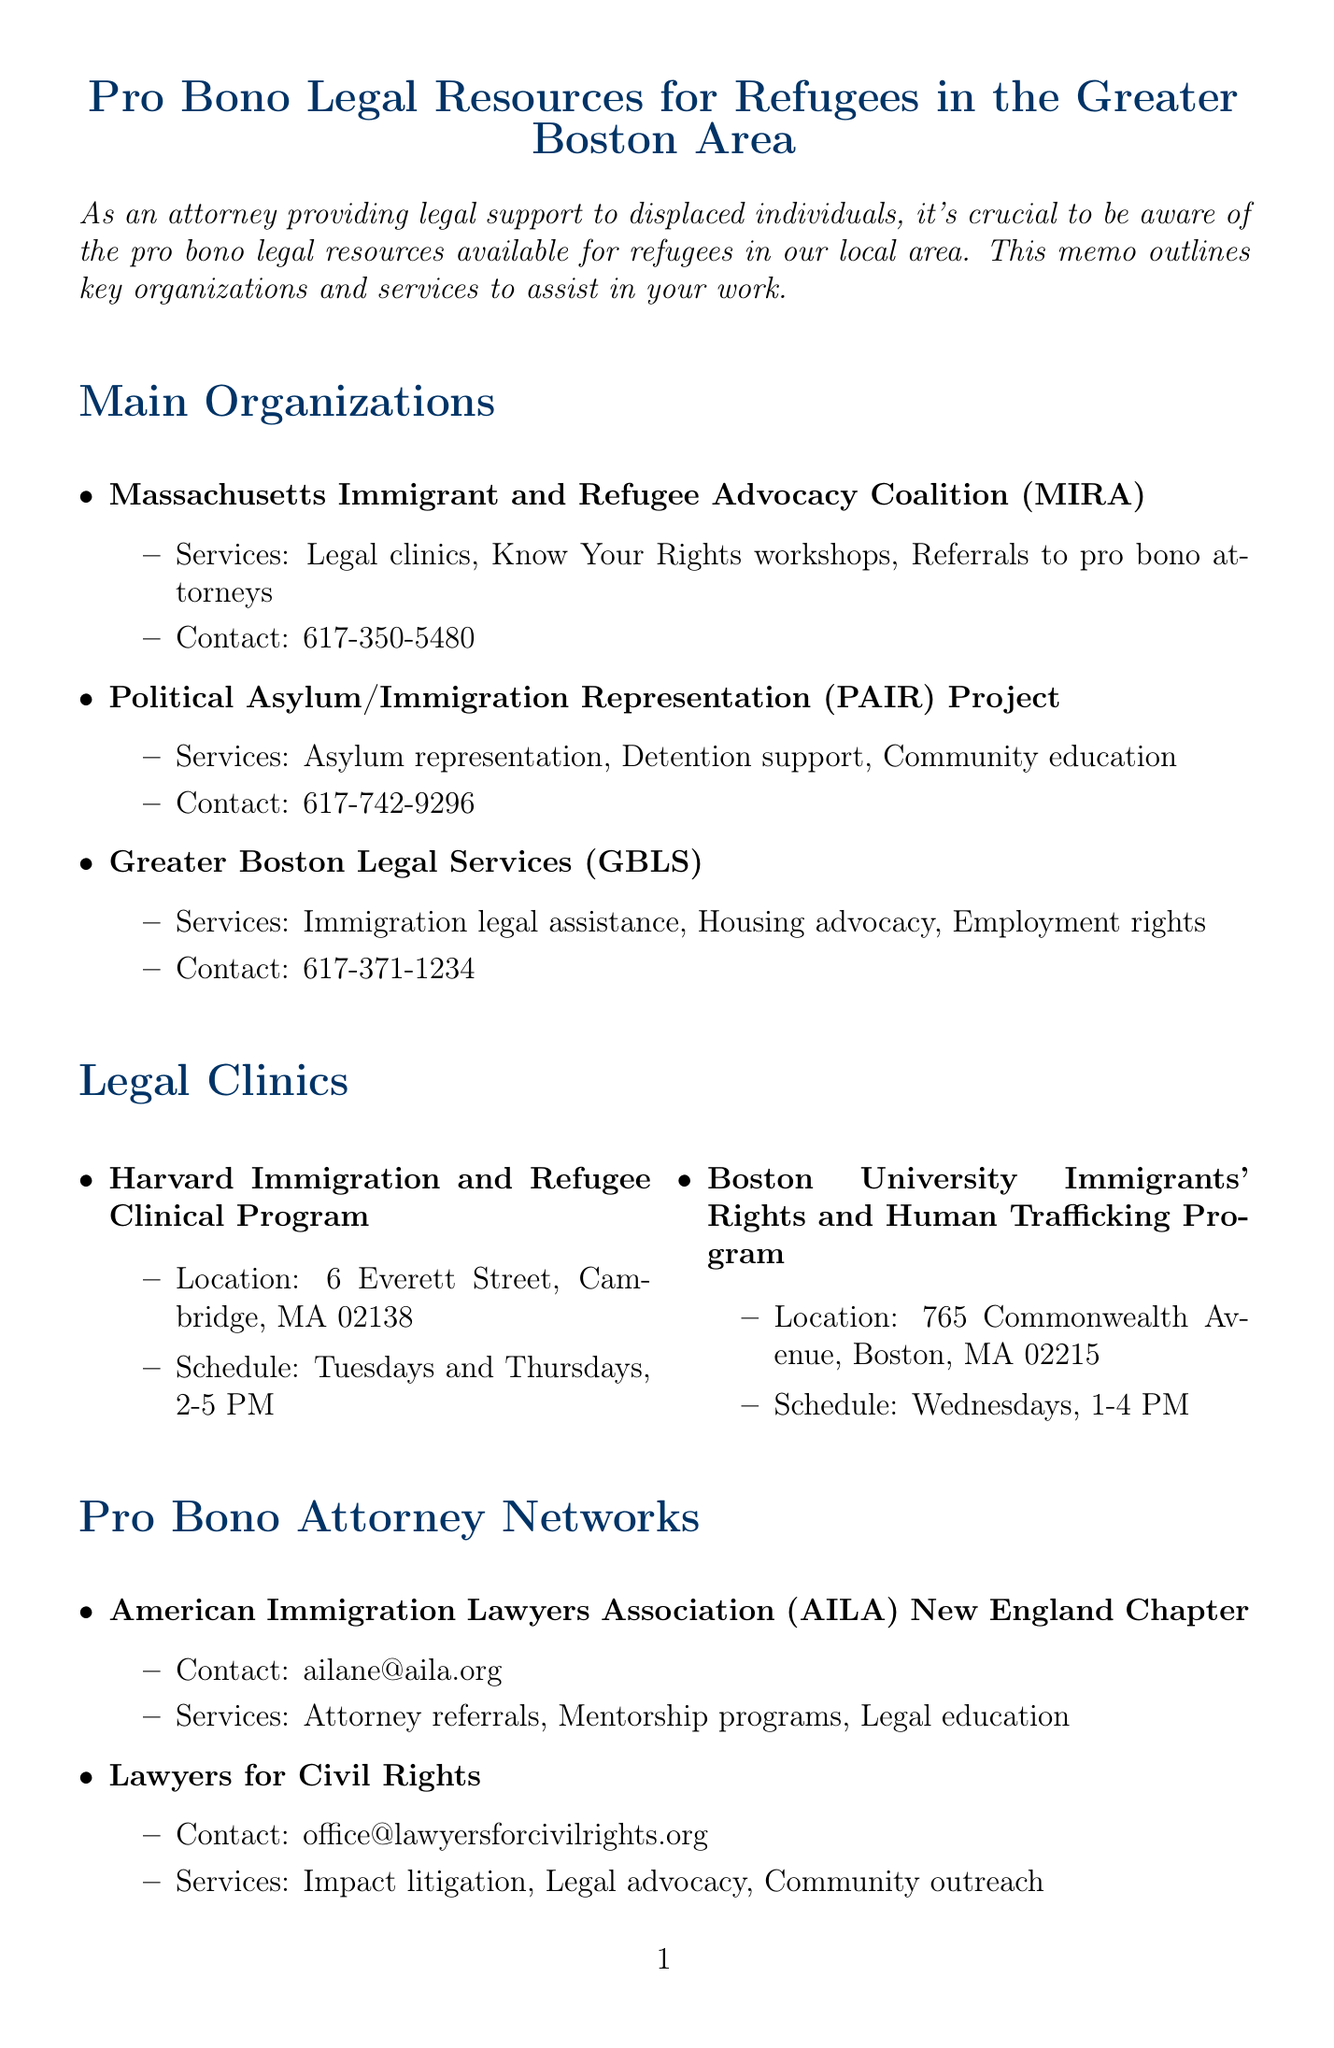What is the title of the memo? The title of the memo is explicitly stated at the beginning of the document.
Answer: Pro Bono Legal Resources for Refugees in the Greater Boston Area How many legal clinics are listed in the document? By counting the individual legal clinics mentioned in the Legal Clinics section.
Answer: 2 What is the contact number for Massachusetts Immigrant and Refugee Advocacy Coalition (MIRA)? The contact information for MIRA is clearly noted in the Main Organizations section.
Answer: 617-350-5480 Which organization provides asylum representation? This requires identifying the organization specifically mentioned for asylum representation in the Main Organizations section.
Answer: PAIR Project What day and time does the Boston University Immigrants' Rights and Human Trafficking Program operate? This is found in the schedule information for that specific legal clinic.
Answer: Wednesdays, 1-4 PM Which organization offers mentorship programs? This organization is specifically noted for providing mentorship programs in the Pro Bono Attorney Networks section.
Answer: AILA New England Chapter What languages does Found in Translation provide interpretation for? The document lists the languages offered by Found in Translation under the Interpretation Services section.
Answer: Spanish, Portuguese, Haitian Creole, Arabic, Mandarin What is the URL for the Massachusetts Legal Resource Finder? This information is mentioned in the Online Resources section of the memo.
Answer: https://masslrf.org/en/home How does this document serve attorneys? This checks the purpose of the memo as described in the introduction.
Answer: To provide legal support and guidance to displaced individuals 